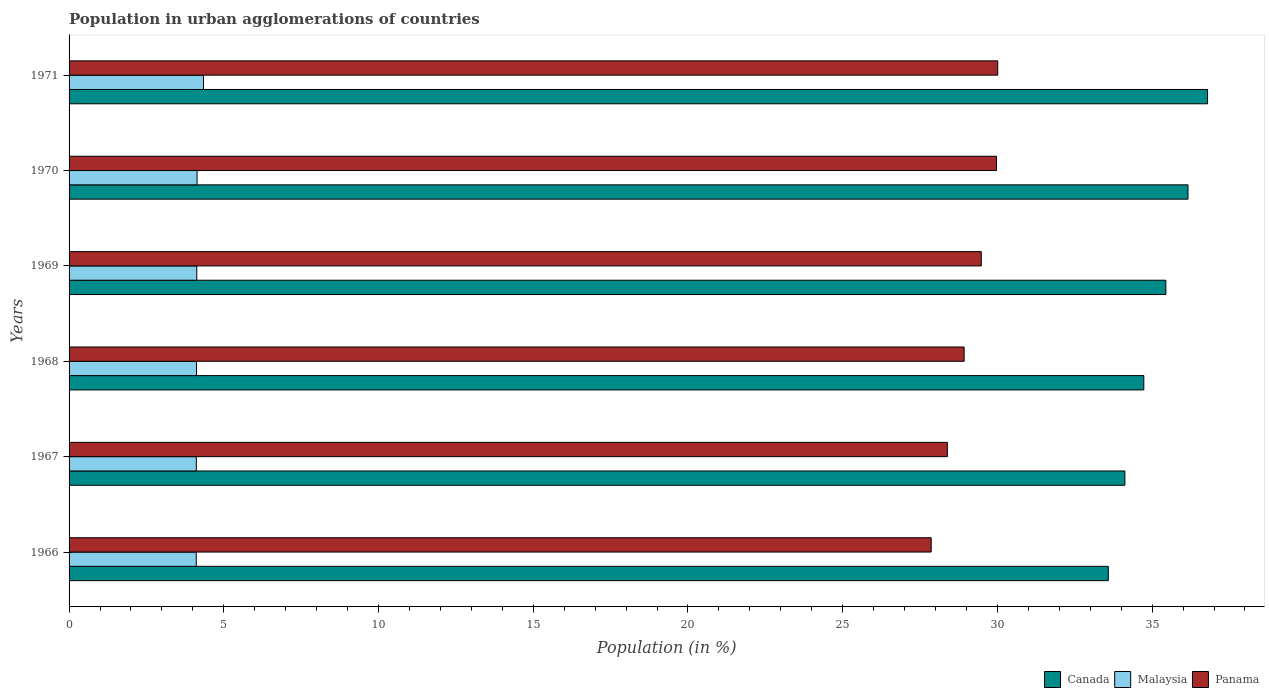How many different coloured bars are there?
Offer a terse response. 3. How many bars are there on the 3rd tick from the bottom?
Give a very brief answer. 3. What is the label of the 4th group of bars from the top?
Make the answer very short. 1968. What is the percentage of population in urban agglomerations in Panama in 1966?
Keep it short and to the point. 27.86. Across all years, what is the maximum percentage of population in urban agglomerations in Canada?
Make the answer very short. 36.79. Across all years, what is the minimum percentage of population in urban agglomerations in Canada?
Give a very brief answer. 33.58. In which year was the percentage of population in urban agglomerations in Canada maximum?
Keep it short and to the point. 1971. In which year was the percentage of population in urban agglomerations in Malaysia minimum?
Make the answer very short. 1966. What is the total percentage of population in urban agglomerations in Canada in the graph?
Your answer should be very brief. 210.82. What is the difference between the percentage of population in urban agglomerations in Canada in 1966 and that in 1970?
Offer a terse response. -2.58. What is the difference between the percentage of population in urban agglomerations in Malaysia in 1967 and the percentage of population in urban agglomerations in Canada in 1968?
Give a very brief answer. -30.62. What is the average percentage of population in urban agglomerations in Malaysia per year?
Your response must be concise. 4.16. In the year 1971, what is the difference between the percentage of population in urban agglomerations in Malaysia and percentage of population in urban agglomerations in Canada?
Provide a short and direct response. -32.45. In how many years, is the percentage of population in urban agglomerations in Canada greater than 6 %?
Provide a short and direct response. 6. What is the ratio of the percentage of population in urban agglomerations in Canada in 1966 to that in 1971?
Give a very brief answer. 0.91. Is the percentage of population in urban agglomerations in Canada in 1968 less than that in 1970?
Offer a terse response. Yes. Is the difference between the percentage of population in urban agglomerations in Malaysia in 1967 and 1968 greater than the difference between the percentage of population in urban agglomerations in Canada in 1967 and 1968?
Keep it short and to the point. Yes. What is the difference between the highest and the second highest percentage of population in urban agglomerations in Panama?
Give a very brief answer. 0.04. What is the difference between the highest and the lowest percentage of population in urban agglomerations in Malaysia?
Your response must be concise. 0.23. What does the 2nd bar from the top in 1967 represents?
Your response must be concise. Malaysia. What does the 3rd bar from the bottom in 1966 represents?
Your answer should be very brief. Panama. Is it the case that in every year, the sum of the percentage of population in urban agglomerations in Panama and percentage of population in urban agglomerations in Canada is greater than the percentage of population in urban agglomerations in Malaysia?
Make the answer very short. Yes. How many bars are there?
Keep it short and to the point. 18. What is the difference between two consecutive major ticks on the X-axis?
Keep it short and to the point. 5. Are the values on the major ticks of X-axis written in scientific E-notation?
Offer a terse response. No. Does the graph contain any zero values?
Keep it short and to the point. No. Does the graph contain grids?
Offer a terse response. No. What is the title of the graph?
Make the answer very short. Population in urban agglomerations of countries. What is the label or title of the X-axis?
Your response must be concise. Population (in %). What is the Population (in %) of Canada in 1966?
Give a very brief answer. 33.58. What is the Population (in %) of Malaysia in 1966?
Offer a terse response. 4.11. What is the Population (in %) of Panama in 1966?
Ensure brevity in your answer.  27.86. What is the Population (in %) of Canada in 1967?
Ensure brevity in your answer.  34.12. What is the Population (in %) of Malaysia in 1967?
Keep it short and to the point. 4.11. What is the Population (in %) of Panama in 1967?
Your response must be concise. 28.38. What is the Population (in %) of Canada in 1968?
Make the answer very short. 34.73. What is the Population (in %) in Malaysia in 1968?
Your response must be concise. 4.12. What is the Population (in %) in Panama in 1968?
Provide a short and direct response. 28.92. What is the Population (in %) of Canada in 1969?
Offer a terse response. 35.44. What is the Population (in %) in Malaysia in 1969?
Your answer should be compact. 4.13. What is the Population (in %) in Panama in 1969?
Your answer should be very brief. 29.48. What is the Population (in %) in Canada in 1970?
Give a very brief answer. 36.16. What is the Population (in %) of Malaysia in 1970?
Provide a short and direct response. 4.14. What is the Population (in %) of Panama in 1970?
Offer a terse response. 29.97. What is the Population (in %) in Canada in 1971?
Ensure brevity in your answer.  36.79. What is the Population (in %) in Malaysia in 1971?
Make the answer very short. 4.34. What is the Population (in %) in Panama in 1971?
Make the answer very short. 30.01. Across all years, what is the maximum Population (in %) in Canada?
Ensure brevity in your answer.  36.79. Across all years, what is the maximum Population (in %) in Malaysia?
Ensure brevity in your answer.  4.34. Across all years, what is the maximum Population (in %) of Panama?
Offer a very short reply. 30.01. Across all years, what is the minimum Population (in %) of Canada?
Your response must be concise. 33.58. Across all years, what is the minimum Population (in %) in Malaysia?
Your answer should be compact. 4.11. Across all years, what is the minimum Population (in %) of Panama?
Offer a terse response. 27.86. What is the total Population (in %) of Canada in the graph?
Provide a succinct answer. 210.82. What is the total Population (in %) of Malaysia in the graph?
Provide a succinct answer. 24.95. What is the total Population (in %) of Panama in the graph?
Give a very brief answer. 174.62. What is the difference between the Population (in %) in Canada in 1966 and that in 1967?
Your answer should be very brief. -0.54. What is the difference between the Population (in %) of Malaysia in 1966 and that in 1967?
Provide a short and direct response. -0. What is the difference between the Population (in %) of Panama in 1966 and that in 1967?
Keep it short and to the point. -0.52. What is the difference between the Population (in %) of Canada in 1966 and that in 1968?
Provide a short and direct response. -1.15. What is the difference between the Population (in %) in Malaysia in 1966 and that in 1968?
Your response must be concise. -0.01. What is the difference between the Population (in %) of Panama in 1966 and that in 1968?
Your answer should be very brief. -1.07. What is the difference between the Population (in %) of Canada in 1966 and that in 1969?
Keep it short and to the point. -1.86. What is the difference between the Population (in %) of Malaysia in 1966 and that in 1969?
Ensure brevity in your answer.  -0.02. What is the difference between the Population (in %) of Panama in 1966 and that in 1969?
Offer a terse response. -1.62. What is the difference between the Population (in %) of Canada in 1966 and that in 1970?
Offer a terse response. -2.58. What is the difference between the Population (in %) of Malaysia in 1966 and that in 1970?
Make the answer very short. -0.03. What is the difference between the Population (in %) in Panama in 1966 and that in 1970?
Your answer should be very brief. -2.11. What is the difference between the Population (in %) in Canada in 1966 and that in 1971?
Keep it short and to the point. -3.21. What is the difference between the Population (in %) of Malaysia in 1966 and that in 1971?
Offer a terse response. -0.23. What is the difference between the Population (in %) of Panama in 1966 and that in 1971?
Keep it short and to the point. -2.15. What is the difference between the Population (in %) in Canada in 1967 and that in 1968?
Provide a succinct answer. -0.61. What is the difference between the Population (in %) of Malaysia in 1967 and that in 1968?
Offer a very short reply. -0.01. What is the difference between the Population (in %) in Panama in 1967 and that in 1968?
Make the answer very short. -0.54. What is the difference between the Population (in %) of Canada in 1967 and that in 1969?
Make the answer very short. -1.32. What is the difference between the Population (in %) of Malaysia in 1967 and that in 1969?
Your answer should be compact. -0.01. What is the difference between the Population (in %) in Panama in 1967 and that in 1969?
Your answer should be compact. -1.09. What is the difference between the Population (in %) in Canada in 1967 and that in 1970?
Your response must be concise. -2.04. What is the difference between the Population (in %) of Malaysia in 1967 and that in 1970?
Keep it short and to the point. -0.02. What is the difference between the Population (in %) of Panama in 1967 and that in 1970?
Keep it short and to the point. -1.59. What is the difference between the Population (in %) of Canada in 1967 and that in 1971?
Your answer should be compact. -2.67. What is the difference between the Population (in %) of Malaysia in 1967 and that in 1971?
Your answer should be very brief. -0.23. What is the difference between the Population (in %) in Panama in 1967 and that in 1971?
Give a very brief answer. -1.63. What is the difference between the Population (in %) of Canada in 1968 and that in 1969?
Ensure brevity in your answer.  -0.71. What is the difference between the Population (in %) in Malaysia in 1968 and that in 1969?
Keep it short and to the point. -0.01. What is the difference between the Population (in %) in Panama in 1968 and that in 1969?
Your answer should be compact. -0.55. What is the difference between the Population (in %) of Canada in 1968 and that in 1970?
Your answer should be very brief. -1.43. What is the difference between the Population (in %) of Malaysia in 1968 and that in 1970?
Your answer should be compact. -0.02. What is the difference between the Population (in %) in Panama in 1968 and that in 1970?
Make the answer very short. -1.05. What is the difference between the Population (in %) in Canada in 1968 and that in 1971?
Your answer should be very brief. -2.06. What is the difference between the Population (in %) of Malaysia in 1968 and that in 1971?
Ensure brevity in your answer.  -0.23. What is the difference between the Population (in %) of Panama in 1968 and that in 1971?
Offer a very short reply. -1.08. What is the difference between the Population (in %) in Canada in 1969 and that in 1970?
Your answer should be compact. -0.72. What is the difference between the Population (in %) of Malaysia in 1969 and that in 1970?
Provide a succinct answer. -0.01. What is the difference between the Population (in %) of Panama in 1969 and that in 1970?
Ensure brevity in your answer.  -0.49. What is the difference between the Population (in %) in Canada in 1969 and that in 1971?
Keep it short and to the point. -1.35. What is the difference between the Population (in %) in Malaysia in 1969 and that in 1971?
Your answer should be very brief. -0.22. What is the difference between the Population (in %) of Panama in 1969 and that in 1971?
Your answer should be compact. -0.53. What is the difference between the Population (in %) in Canada in 1970 and that in 1971?
Provide a short and direct response. -0.63. What is the difference between the Population (in %) in Malaysia in 1970 and that in 1971?
Your answer should be compact. -0.21. What is the difference between the Population (in %) of Panama in 1970 and that in 1971?
Offer a very short reply. -0.04. What is the difference between the Population (in %) in Canada in 1966 and the Population (in %) in Malaysia in 1967?
Provide a succinct answer. 29.47. What is the difference between the Population (in %) of Canada in 1966 and the Population (in %) of Panama in 1967?
Keep it short and to the point. 5.2. What is the difference between the Population (in %) in Malaysia in 1966 and the Population (in %) in Panama in 1967?
Give a very brief answer. -24.27. What is the difference between the Population (in %) in Canada in 1966 and the Population (in %) in Malaysia in 1968?
Give a very brief answer. 29.46. What is the difference between the Population (in %) in Canada in 1966 and the Population (in %) in Panama in 1968?
Make the answer very short. 4.66. What is the difference between the Population (in %) of Malaysia in 1966 and the Population (in %) of Panama in 1968?
Your response must be concise. -24.81. What is the difference between the Population (in %) in Canada in 1966 and the Population (in %) in Malaysia in 1969?
Provide a succinct answer. 29.46. What is the difference between the Population (in %) in Canada in 1966 and the Population (in %) in Panama in 1969?
Provide a succinct answer. 4.11. What is the difference between the Population (in %) of Malaysia in 1966 and the Population (in %) of Panama in 1969?
Keep it short and to the point. -25.37. What is the difference between the Population (in %) in Canada in 1966 and the Population (in %) in Malaysia in 1970?
Your answer should be compact. 29.45. What is the difference between the Population (in %) of Canada in 1966 and the Population (in %) of Panama in 1970?
Make the answer very short. 3.61. What is the difference between the Population (in %) of Malaysia in 1966 and the Population (in %) of Panama in 1970?
Your answer should be compact. -25.86. What is the difference between the Population (in %) in Canada in 1966 and the Population (in %) in Malaysia in 1971?
Provide a succinct answer. 29.24. What is the difference between the Population (in %) of Canada in 1966 and the Population (in %) of Panama in 1971?
Give a very brief answer. 3.57. What is the difference between the Population (in %) in Malaysia in 1966 and the Population (in %) in Panama in 1971?
Give a very brief answer. -25.9. What is the difference between the Population (in %) in Canada in 1967 and the Population (in %) in Malaysia in 1968?
Make the answer very short. 30. What is the difference between the Population (in %) of Canada in 1967 and the Population (in %) of Panama in 1968?
Offer a very short reply. 5.19. What is the difference between the Population (in %) in Malaysia in 1967 and the Population (in %) in Panama in 1968?
Provide a short and direct response. -24.81. What is the difference between the Population (in %) in Canada in 1967 and the Population (in %) in Malaysia in 1969?
Your answer should be compact. 29.99. What is the difference between the Population (in %) of Canada in 1967 and the Population (in %) of Panama in 1969?
Your response must be concise. 4.64. What is the difference between the Population (in %) in Malaysia in 1967 and the Population (in %) in Panama in 1969?
Offer a very short reply. -25.37. What is the difference between the Population (in %) in Canada in 1967 and the Population (in %) in Malaysia in 1970?
Provide a succinct answer. 29.98. What is the difference between the Population (in %) in Canada in 1967 and the Population (in %) in Panama in 1970?
Your answer should be very brief. 4.15. What is the difference between the Population (in %) in Malaysia in 1967 and the Population (in %) in Panama in 1970?
Provide a succinct answer. -25.86. What is the difference between the Population (in %) of Canada in 1967 and the Population (in %) of Malaysia in 1971?
Your response must be concise. 29.77. What is the difference between the Population (in %) of Canada in 1967 and the Population (in %) of Panama in 1971?
Ensure brevity in your answer.  4.11. What is the difference between the Population (in %) in Malaysia in 1967 and the Population (in %) in Panama in 1971?
Your response must be concise. -25.9. What is the difference between the Population (in %) in Canada in 1968 and the Population (in %) in Malaysia in 1969?
Your answer should be very brief. 30.6. What is the difference between the Population (in %) of Canada in 1968 and the Population (in %) of Panama in 1969?
Make the answer very short. 5.25. What is the difference between the Population (in %) of Malaysia in 1968 and the Population (in %) of Panama in 1969?
Make the answer very short. -25.36. What is the difference between the Population (in %) in Canada in 1968 and the Population (in %) in Malaysia in 1970?
Provide a succinct answer. 30.59. What is the difference between the Population (in %) in Canada in 1968 and the Population (in %) in Panama in 1970?
Your answer should be very brief. 4.76. What is the difference between the Population (in %) in Malaysia in 1968 and the Population (in %) in Panama in 1970?
Your response must be concise. -25.85. What is the difference between the Population (in %) of Canada in 1968 and the Population (in %) of Malaysia in 1971?
Provide a succinct answer. 30.39. What is the difference between the Population (in %) in Canada in 1968 and the Population (in %) in Panama in 1971?
Offer a terse response. 4.72. What is the difference between the Population (in %) of Malaysia in 1968 and the Population (in %) of Panama in 1971?
Offer a very short reply. -25.89. What is the difference between the Population (in %) of Canada in 1969 and the Population (in %) of Malaysia in 1970?
Provide a succinct answer. 31.31. What is the difference between the Population (in %) of Canada in 1969 and the Population (in %) of Panama in 1970?
Keep it short and to the point. 5.47. What is the difference between the Population (in %) in Malaysia in 1969 and the Population (in %) in Panama in 1970?
Offer a very short reply. -25.84. What is the difference between the Population (in %) of Canada in 1969 and the Population (in %) of Malaysia in 1971?
Ensure brevity in your answer.  31.1. What is the difference between the Population (in %) of Canada in 1969 and the Population (in %) of Panama in 1971?
Your response must be concise. 5.43. What is the difference between the Population (in %) in Malaysia in 1969 and the Population (in %) in Panama in 1971?
Make the answer very short. -25.88. What is the difference between the Population (in %) in Canada in 1970 and the Population (in %) in Malaysia in 1971?
Offer a terse response. 31.81. What is the difference between the Population (in %) in Canada in 1970 and the Population (in %) in Panama in 1971?
Offer a terse response. 6.15. What is the difference between the Population (in %) in Malaysia in 1970 and the Population (in %) in Panama in 1971?
Make the answer very short. -25.87. What is the average Population (in %) of Canada per year?
Make the answer very short. 35.14. What is the average Population (in %) in Malaysia per year?
Your answer should be compact. 4.16. What is the average Population (in %) of Panama per year?
Keep it short and to the point. 29.1. In the year 1966, what is the difference between the Population (in %) in Canada and Population (in %) in Malaysia?
Offer a very short reply. 29.47. In the year 1966, what is the difference between the Population (in %) of Canada and Population (in %) of Panama?
Provide a short and direct response. 5.72. In the year 1966, what is the difference between the Population (in %) in Malaysia and Population (in %) in Panama?
Your answer should be compact. -23.75. In the year 1967, what is the difference between the Population (in %) in Canada and Population (in %) in Malaysia?
Ensure brevity in your answer.  30.01. In the year 1967, what is the difference between the Population (in %) of Canada and Population (in %) of Panama?
Your answer should be compact. 5.74. In the year 1967, what is the difference between the Population (in %) of Malaysia and Population (in %) of Panama?
Keep it short and to the point. -24.27. In the year 1968, what is the difference between the Population (in %) of Canada and Population (in %) of Malaysia?
Ensure brevity in your answer.  30.61. In the year 1968, what is the difference between the Population (in %) in Canada and Population (in %) in Panama?
Your answer should be very brief. 5.81. In the year 1968, what is the difference between the Population (in %) of Malaysia and Population (in %) of Panama?
Your answer should be compact. -24.81. In the year 1969, what is the difference between the Population (in %) in Canada and Population (in %) in Malaysia?
Ensure brevity in your answer.  31.32. In the year 1969, what is the difference between the Population (in %) of Canada and Population (in %) of Panama?
Ensure brevity in your answer.  5.96. In the year 1969, what is the difference between the Population (in %) in Malaysia and Population (in %) in Panama?
Provide a short and direct response. -25.35. In the year 1970, what is the difference between the Population (in %) of Canada and Population (in %) of Malaysia?
Provide a short and direct response. 32.02. In the year 1970, what is the difference between the Population (in %) of Canada and Population (in %) of Panama?
Your answer should be very brief. 6.19. In the year 1970, what is the difference between the Population (in %) of Malaysia and Population (in %) of Panama?
Your response must be concise. -25.83. In the year 1971, what is the difference between the Population (in %) in Canada and Population (in %) in Malaysia?
Your response must be concise. 32.45. In the year 1971, what is the difference between the Population (in %) of Canada and Population (in %) of Panama?
Offer a terse response. 6.78. In the year 1971, what is the difference between the Population (in %) in Malaysia and Population (in %) in Panama?
Keep it short and to the point. -25.67. What is the ratio of the Population (in %) of Canada in 1966 to that in 1967?
Give a very brief answer. 0.98. What is the ratio of the Population (in %) of Panama in 1966 to that in 1967?
Your answer should be very brief. 0.98. What is the ratio of the Population (in %) in Malaysia in 1966 to that in 1968?
Provide a succinct answer. 1. What is the ratio of the Population (in %) of Panama in 1966 to that in 1968?
Your answer should be very brief. 0.96. What is the ratio of the Population (in %) of Canada in 1966 to that in 1969?
Your response must be concise. 0.95. What is the ratio of the Population (in %) of Malaysia in 1966 to that in 1969?
Offer a terse response. 1. What is the ratio of the Population (in %) of Panama in 1966 to that in 1969?
Keep it short and to the point. 0.95. What is the ratio of the Population (in %) in Canada in 1966 to that in 1970?
Offer a terse response. 0.93. What is the ratio of the Population (in %) in Panama in 1966 to that in 1970?
Offer a very short reply. 0.93. What is the ratio of the Population (in %) in Canada in 1966 to that in 1971?
Provide a short and direct response. 0.91. What is the ratio of the Population (in %) of Malaysia in 1966 to that in 1971?
Your answer should be very brief. 0.95. What is the ratio of the Population (in %) in Panama in 1966 to that in 1971?
Your response must be concise. 0.93. What is the ratio of the Population (in %) in Canada in 1967 to that in 1968?
Provide a short and direct response. 0.98. What is the ratio of the Population (in %) in Panama in 1967 to that in 1968?
Provide a short and direct response. 0.98. What is the ratio of the Population (in %) of Canada in 1967 to that in 1969?
Provide a short and direct response. 0.96. What is the ratio of the Population (in %) in Malaysia in 1967 to that in 1969?
Make the answer very short. 1. What is the ratio of the Population (in %) in Panama in 1967 to that in 1969?
Make the answer very short. 0.96. What is the ratio of the Population (in %) of Canada in 1967 to that in 1970?
Your response must be concise. 0.94. What is the ratio of the Population (in %) of Panama in 1967 to that in 1970?
Provide a short and direct response. 0.95. What is the ratio of the Population (in %) in Canada in 1967 to that in 1971?
Your answer should be very brief. 0.93. What is the ratio of the Population (in %) in Malaysia in 1967 to that in 1971?
Give a very brief answer. 0.95. What is the ratio of the Population (in %) in Panama in 1967 to that in 1971?
Provide a short and direct response. 0.95. What is the ratio of the Population (in %) in Canada in 1968 to that in 1969?
Your answer should be compact. 0.98. What is the ratio of the Population (in %) of Malaysia in 1968 to that in 1969?
Give a very brief answer. 1. What is the ratio of the Population (in %) of Panama in 1968 to that in 1969?
Offer a very short reply. 0.98. What is the ratio of the Population (in %) of Canada in 1968 to that in 1970?
Keep it short and to the point. 0.96. What is the ratio of the Population (in %) in Panama in 1968 to that in 1970?
Your answer should be very brief. 0.97. What is the ratio of the Population (in %) of Canada in 1968 to that in 1971?
Keep it short and to the point. 0.94. What is the ratio of the Population (in %) in Malaysia in 1968 to that in 1971?
Provide a short and direct response. 0.95. What is the ratio of the Population (in %) of Panama in 1968 to that in 1971?
Keep it short and to the point. 0.96. What is the ratio of the Population (in %) in Canada in 1969 to that in 1970?
Ensure brevity in your answer.  0.98. What is the ratio of the Population (in %) in Panama in 1969 to that in 1970?
Offer a very short reply. 0.98. What is the ratio of the Population (in %) of Canada in 1969 to that in 1971?
Your answer should be compact. 0.96. What is the ratio of the Population (in %) in Malaysia in 1969 to that in 1971?
Make the answer very short. 0.95. What is the ratio of the Population (in %) of Panama in 1969 to that in 1971?
Offer a terse response. 0.98. What is the ratio of the Population (in %) of Canada in 1970 to that in 1971?
Provide a succinct answer. 0.98. What is the ratio of the Population (in %) in Malaysia in 1970 to that in 1971?
Your response must be concise. 0.95. What is the ratio of the Population (in %) of Panama in 1970 to that in 1971?
Your answer should be very brief. 1. What is the difference between the highest and the second highest Population (in %) in Canada?
Your answer should be compact. 0.63. What is the difference between the highest and the second highest Population (in %) of Malaysia?
Provide a short and direct response. 0.21. What is the difference between the highest and the second highest Population (in %) in Panama?
Make the answer very short. 0.04. What is the difference between the highest and the lowest Population (in %) in Canada?
Make the answer very short. 3.21. What is the difference between the highest and the lowest Population (in %) of Malaysia?
Keep it short and to the point. 0.23. What is the difference between the highest and the lowest Population (in %) in Panama?
Make the answer very short. 2.15. 